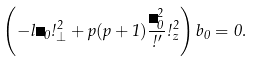<formula> <loc_0><loc_0><loc_500><loc_500>\left ( - l \Omega _ { 0 } \omega _ { \perp } ^ { 2 } + p ( p + 1 ) \frac { \Omega _ { 0 } ^ { 2 } } { \omega ^ { \prime } } \omega _ { z } ^ { 2 } \right ) b _ { 0 } = 0 .</formula> 